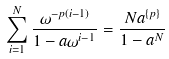Convert formula to latex. <formula><loc_0><loc_0><loc_500><loc_500>\sum _ { i = 1 } ^ { N } \frac { \omega ^ { - p ( i - 1 ) } } { 1 - a \omega ^ { i - 1 } } = \frac { N a ^ { \{ p \} } } { 1 - a ^ { N } }</formula> 